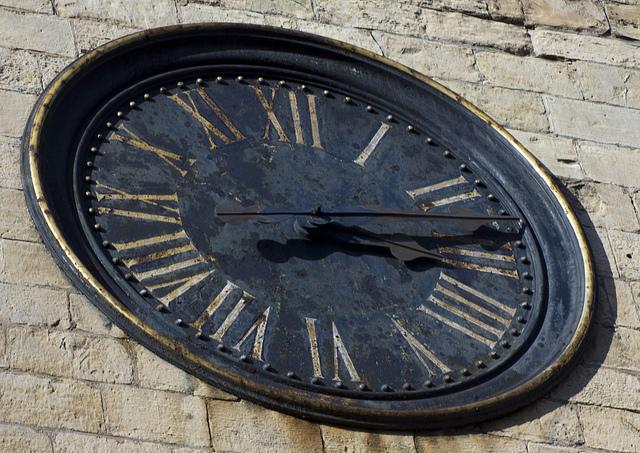Is the clock old?
Concise answer only. Yes. Are the numbers on this clock in Roman numerals?
Be succinct. Yes. Is the clock rusting?
Be succinct. Yes. 